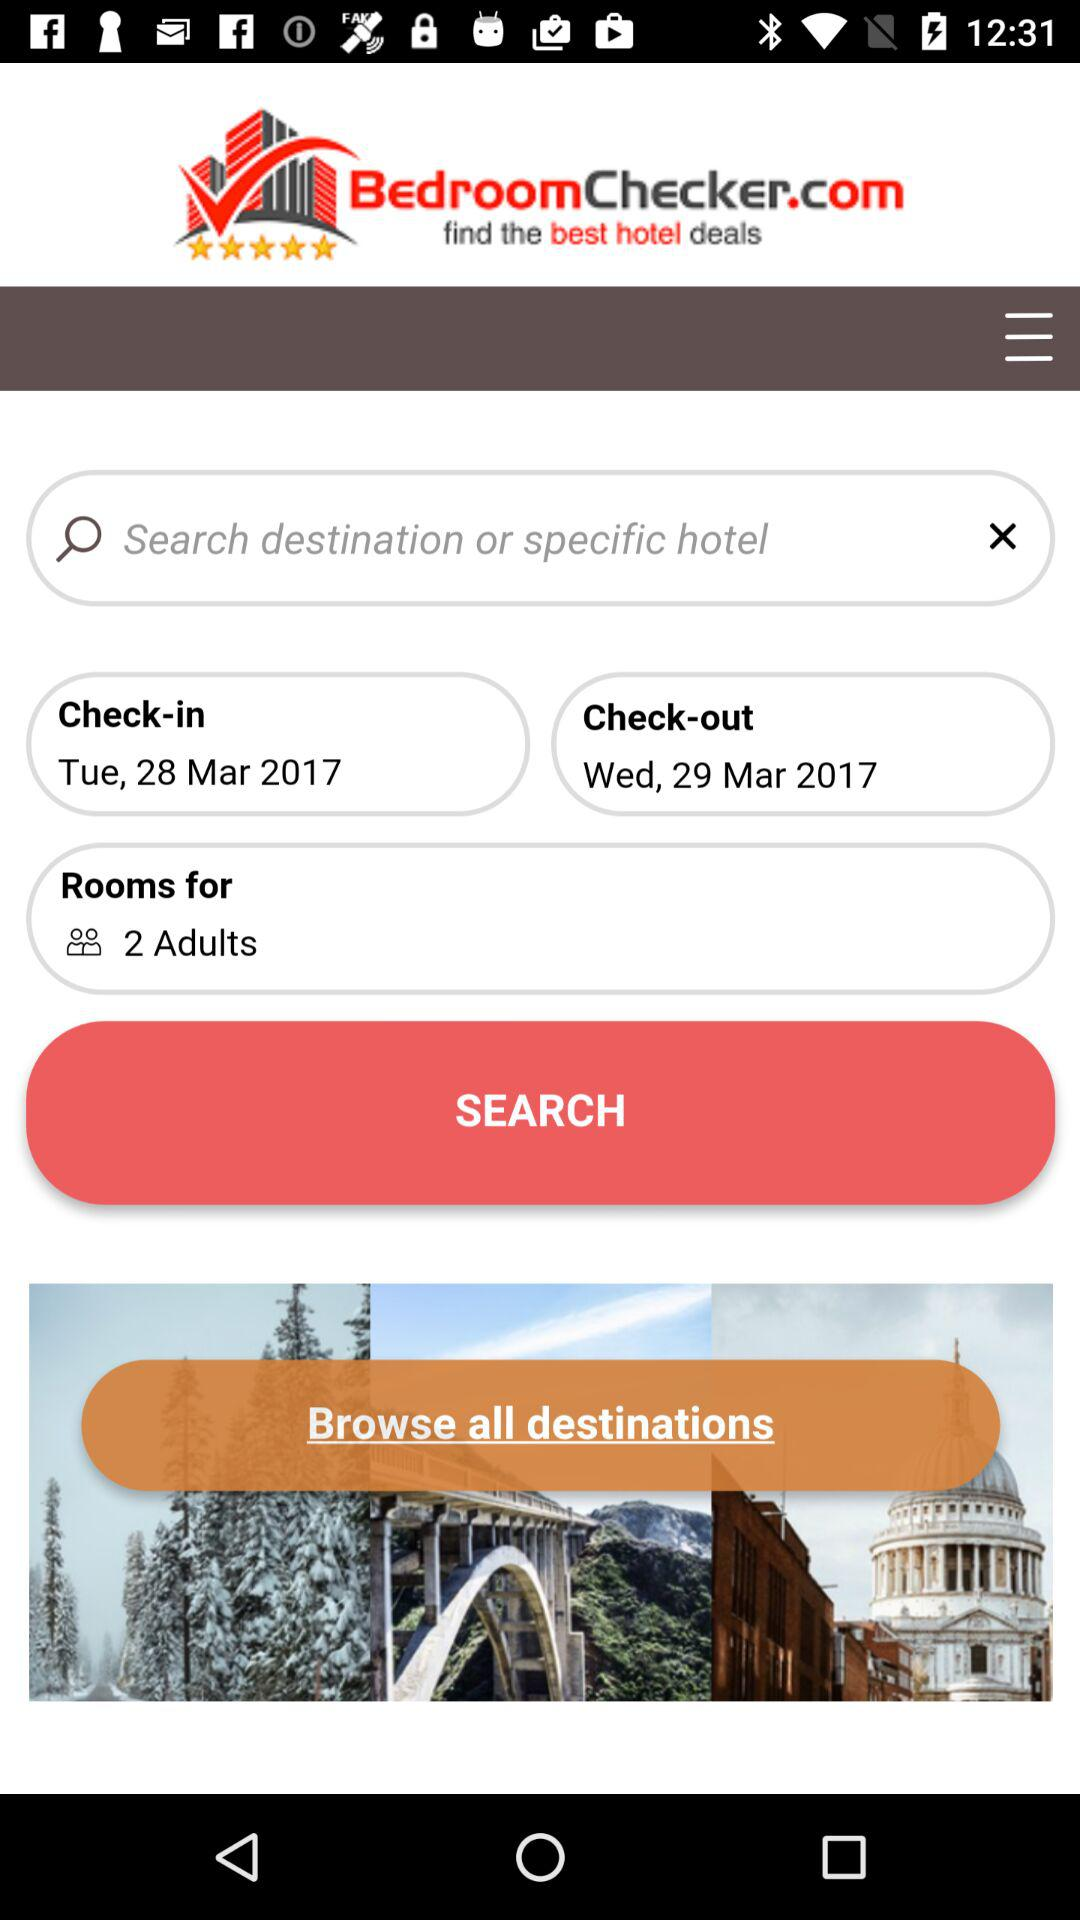What is the check-in date? The check-in date is Tuesday, March 28, 2017. 